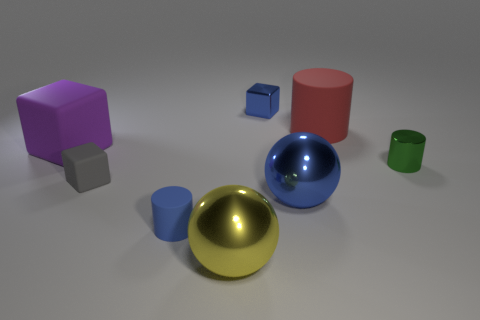Add 2 big purple rubber objects. How many objects exist? 10 Subtract all blocks. How many objects are left? 5 Subtract all small objects. Subtract all big blue things. How many objects are left? 3 Add 4 big yellow metallic objects. How many big yellow metallic objects are left? 5 Add 3 large red things. How many large red things exist? 4 Subtract 0 green balls. How many objects are left? 8 